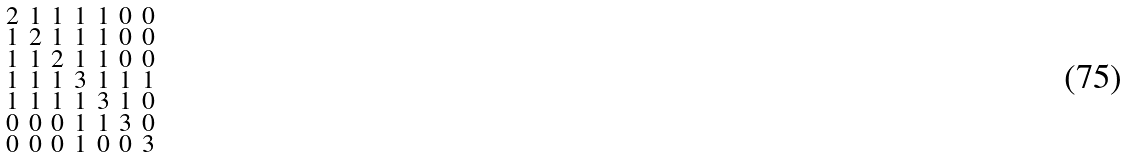<formula> <loc_0><loc_0><loc_500><loc_500>\begin{smallmatrix} 2 & 1 & 1 & 1 & 1 & 0 & 0 \\ 1 & 2 & 1 & 1 & 1 & 0 & 0 \\ 1 & 1 & 2 & 1 & 1 & 0 & 0 \\ 1 & 1 & 1 & 3 & 1 & 1 & 1 \\ 1 & 1 & 1 & 1 & 3 & 1 & 0 \\ 0 & 0 & 0 & 1 & 1 & 3 & 0 \\ 0 & 0 & 0 & 1 & 0 & 0 & 3 \end{smallmatrix}</formula> 